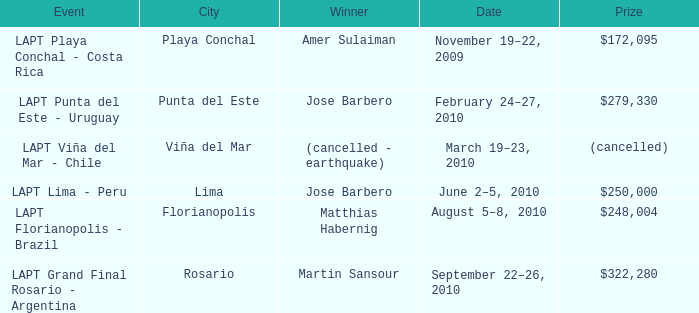What is the date amer sulaiman won? November 19–22, 2009. 